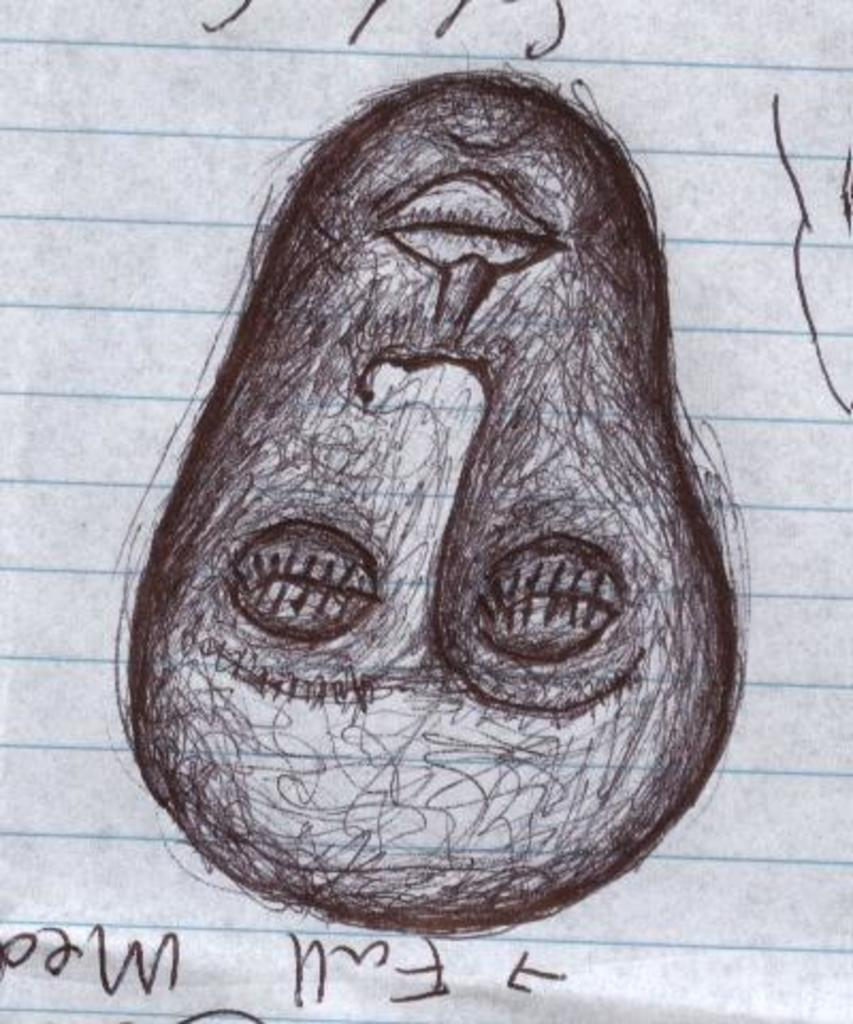What is depicted on the paper in the image? The paper contains a drawing of a face. What else can be seen on the paper besides the drawing? There is text at the bottom of the paper. What color is the skirt worn by the person in the image? There is no person wearing a skirt in the image; it only contains a paper with a drawing of a face and text. 